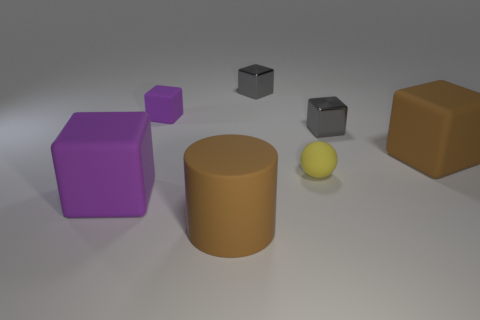What number of yellow things are matte balls or big matte blocks?
Give a very brief answer. 1. Is the number of tiny gray metal things greater than the number of tiny balls?
Provide a succinct answer. Yes. Do the shiny thing to the right of the small ball and the ball that is in front of the tiny purple thing have the same size?
Your answer should be very brief. Yes. The big rubber object that is in front of the purple rubber cube in front of the brown thing that is behind the big purple matte thing is what color?
Your answer should be compact. Brown. Are there any large green metal objects that have the same shape as the small yellow matte object?
Give a very brief answer. No. Are there more rubber blocks that are on the left side of the sphere than big cyan spheres?
Provide a short and direct response. Yes. What number of shiny objects are either small purple spheres or tiny yellow things?
Ensure brevity in your answer.  0. How big is the matte block that is both in front of the tiny purple thing and on the right side of the large purple matte cube?
Offer a terse response. Large. There is a large rubber cube behind the large purple thing; are there any cylinders that are left of it?
Offer a terse response. Yes. There is a small purple rubber block; how many shiny blocks are in front of it?
Offer a terse response. 1. 